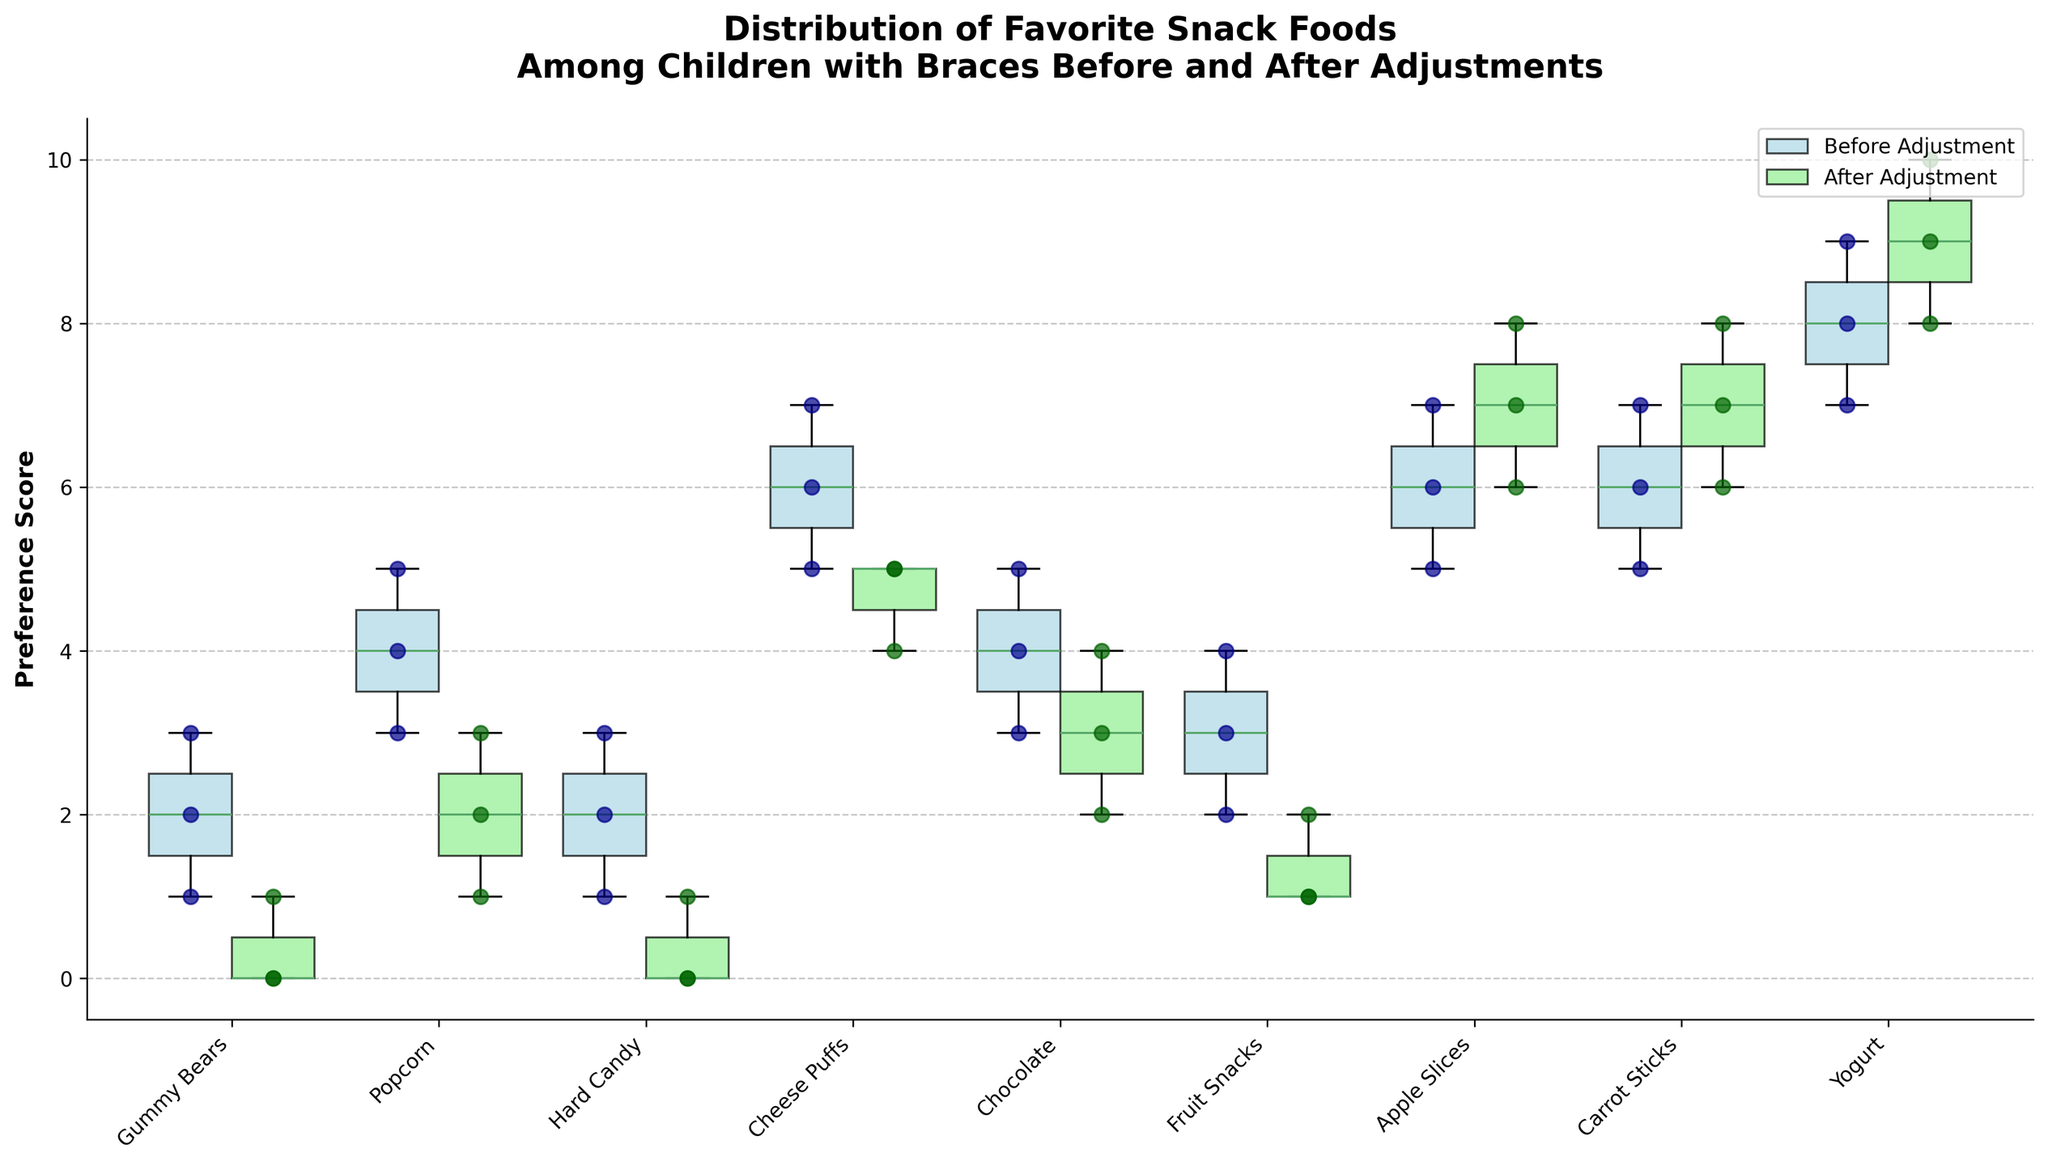What's the title of the figure? The title is located at the top of the figure, summarizing what the plot is about.
Answer: Distribution of Favorite Snack Foods Among Children with Braces Before and After Adjustments What do the blue and green box plots represent? The legend at the top right corner of the figure explains the colors. Blue represents "Before Adjustment" and green represents "After Adjustment".
Answer: Before Adjustment (blue), After Adjustment (green) Which snack do children tend to prefer the most after adjustment? By looking at the highest values in the green box plots, we see that Yogurt has the highest range of preference scores after adjustments.
Answer: Yogurt What is the median preference score for Carrot Sticks before adjustments? The median is represented by the line inside the blue box plot for Carrot Sticks. The line appears to be at 6.
Answer: 6 Which snack shows the greatest decrease in median preference score after adjustment? To find this, compare the median lines of the snacks in the blue and green box plots. Gummy Bears show a drop from 2 (before) to 0 (after).
Answer: Gummy Bears How does the range of preference scores for Chocolate compare before and after adjustment? Looking at the length of the box plots for Chocolate, before adjustment the range is from 3 to 5, and after adjustment it is from 2 to 4, showing a slight shrink in range.
Answer: Narrowed Which snacks show no change in median preference score after adjustments? By comparing the medians in the blue and green box plots, see which snacks have the same median in both. Apple Slices and Carrot Sticks have unchanged medians.
Answer: Apple Slices, Carrot Sticks Are there any snacks where the preference score increased after adjustments? Comparing the scores before and after adjustments, see which ones have a higher median or more data points. Apple Slices, Carrot Sticks, and Yogurt show an increase after adjustments.
Answer: Apple Slices, Carrot Sticks, Yogurt What is the minimum preference score for Popcorn before adjustments? The minimum value is the lowest point below the whiskers of the blue box plot for Popcorn, which is 3.
Answer: 3 How many total data points are there for Cheese Puffs after adjustments? There are individual scatter points for each data entry. Counting the green points for Cheese Puffs will show there are three.
Answer: 3 